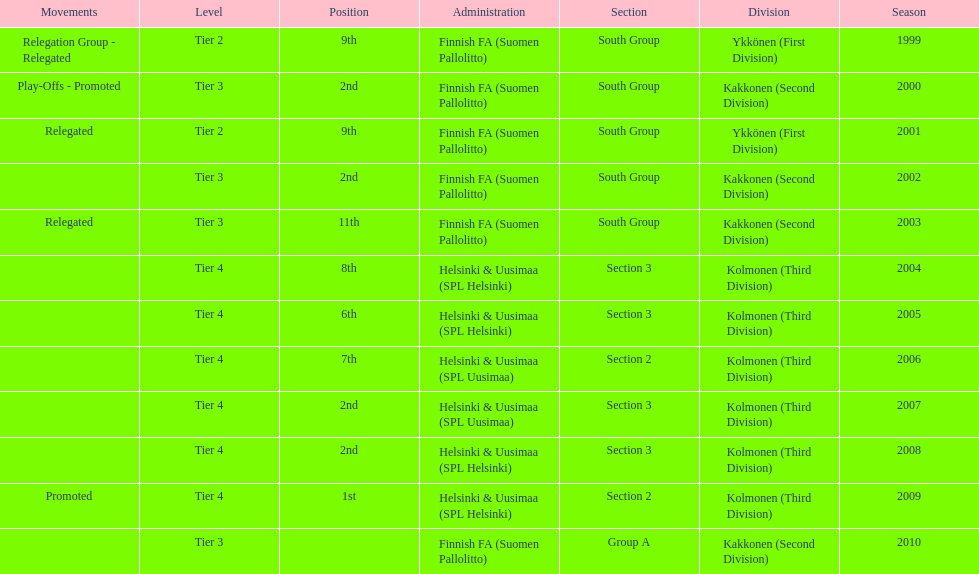In which subdivision were they primarily, part 3 or 2? 3. 